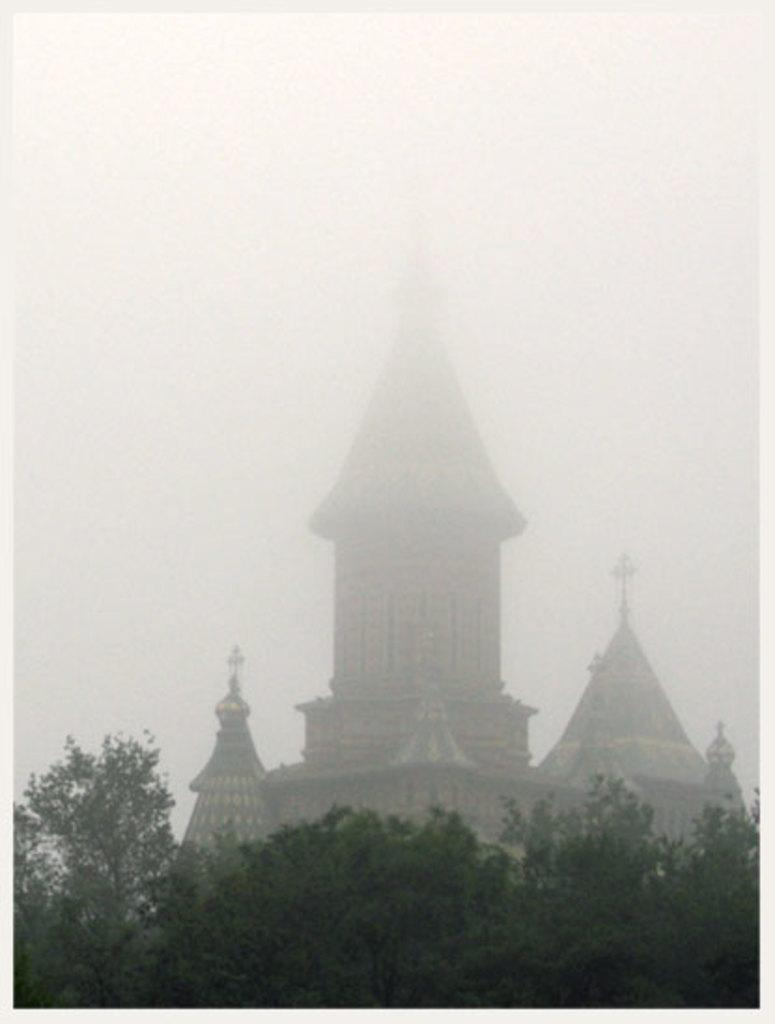What type of structure is present in the image? There is a building in the image. What natural elements can be seen in the image? There are many trees in the image. What part of the environment is visible in the image? The sky is visible in the image. What color is the crayon used to draw the scene in the image? There is no crayon or drawing present in the image; it is a photograph of a building, trees, and the sky. 